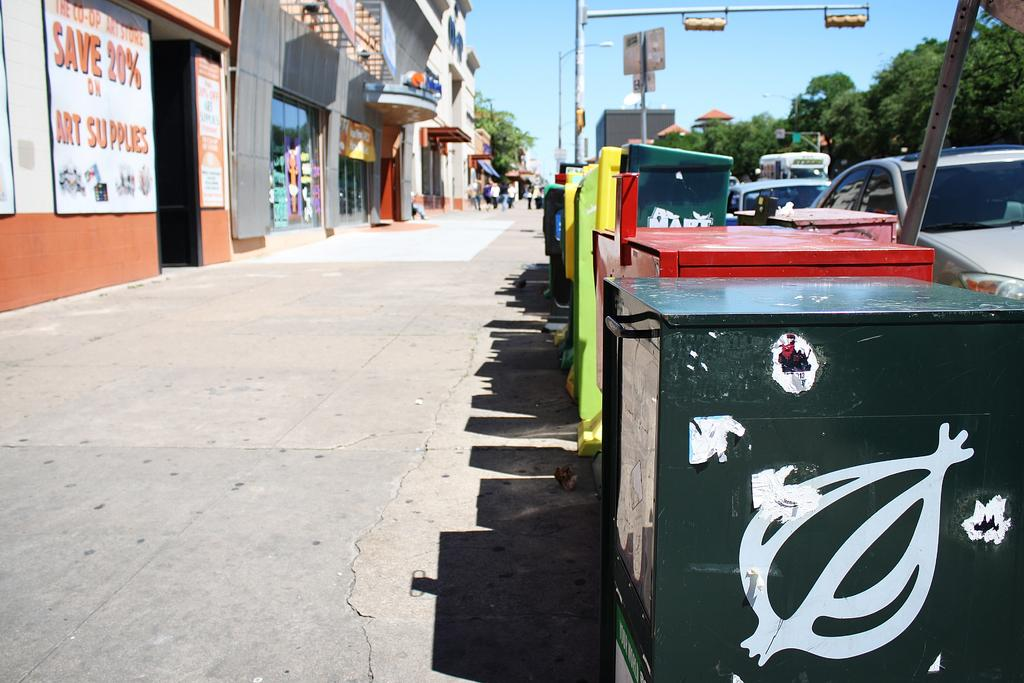Provide a one-sentence caption for the provided image. A long shot of a street side with a sign for saving 20% in art supplies on a building. 